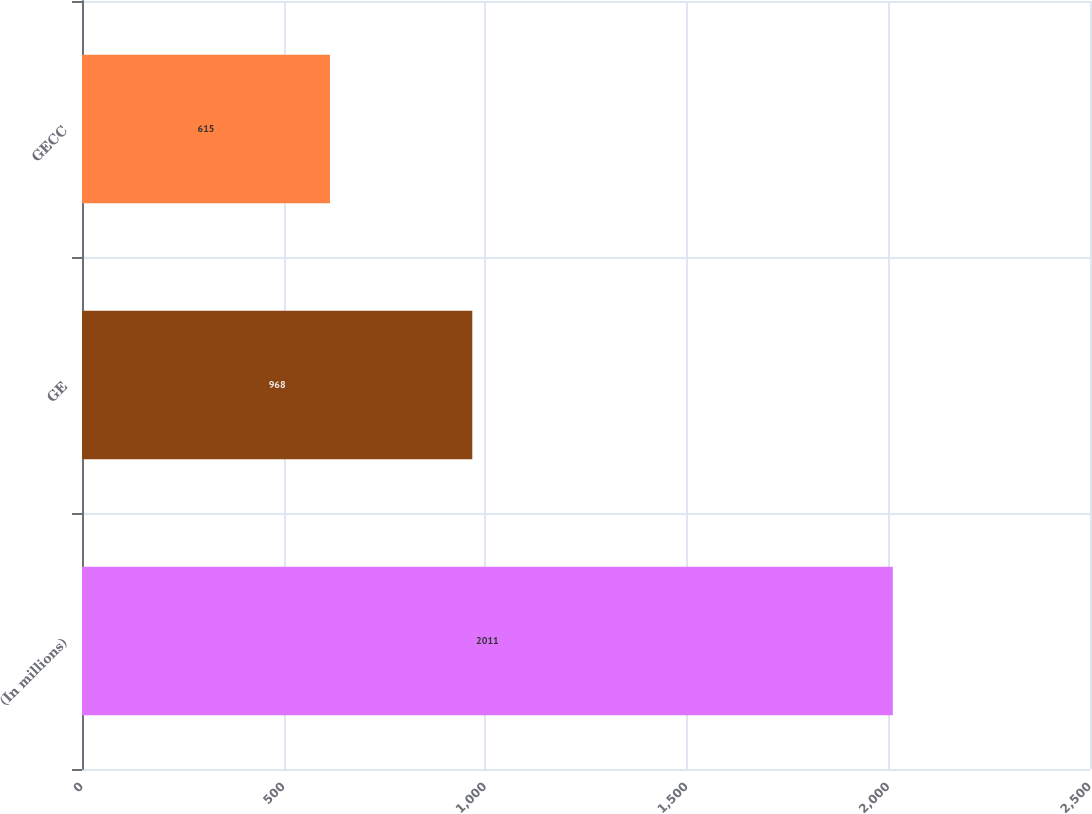Convert chart to OTSL. <chart><loc_0><loc_0><loc_500><loc_500><bar_chart><fcel>(In millions)<fcel>GE<fcel>GECC<nl><fcel>2011<fcel>968<fcel>615<nl></chart> 